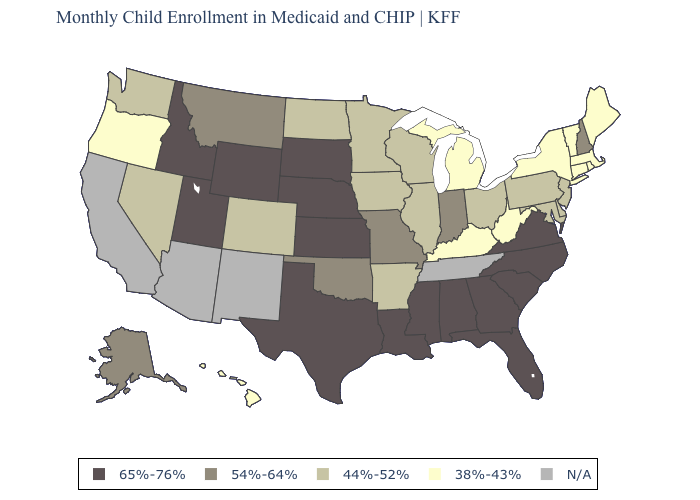Does Louisiana have the highest value in the South?
Quick response, please. Yes. Which states hav the highest value in the West?
Keep it brief. Idaho, Utah, Wyoming. What is the highest value in the Northeast ?
Short answer required. 54%-64%. Name the states that have a value in the range 38%-43%?
Short answer required. Connecticut, Hawaii, Kentucky, Maine, Massachusetts, Michigan, New York, Oregon, Rhode Island, Vermont, West Virginia. Does the map have missing data?
Give a very brief answer. Yes. Does Oregon have the highest value in the USA?
Answer briefly. No. Name the states that have a value in the range 44%-52%?
Give a very brief answer. Arkansas, Colorado, Delaware, Illinois, Iowa, Maryland, Minnesota, Nevada, New Jersey, North Dakota, Ohio, Pennsylvania, Washington, Wisconsin. What is the value of Florida?
Keep it brief. 65%-76%. What is the highest value in the MidWest ?
Quick response, please. 65%-76%. Name the states that have a value in the range 44%-52%?
Give a very brief answer. Arkansas, Colorado, Delaware, Illinois, Iowa, Maryland, Minnesota, Nevada, New Jersey, North Dakota, Ohio, Pennsylvania, Washington, Wisconsin. Does the map have missing data?
Answer briefly. Yes. What is the value of Kansas?
Keep it brief. 65%-76%. Which states have the lowest value in the Northeast?
Be succinct. Connecticut, Maine, Massachusetts, New York, Rhode Island, Vermont. Does Mississippi have the highest value in the USA?
Keep it brief. Yes. 